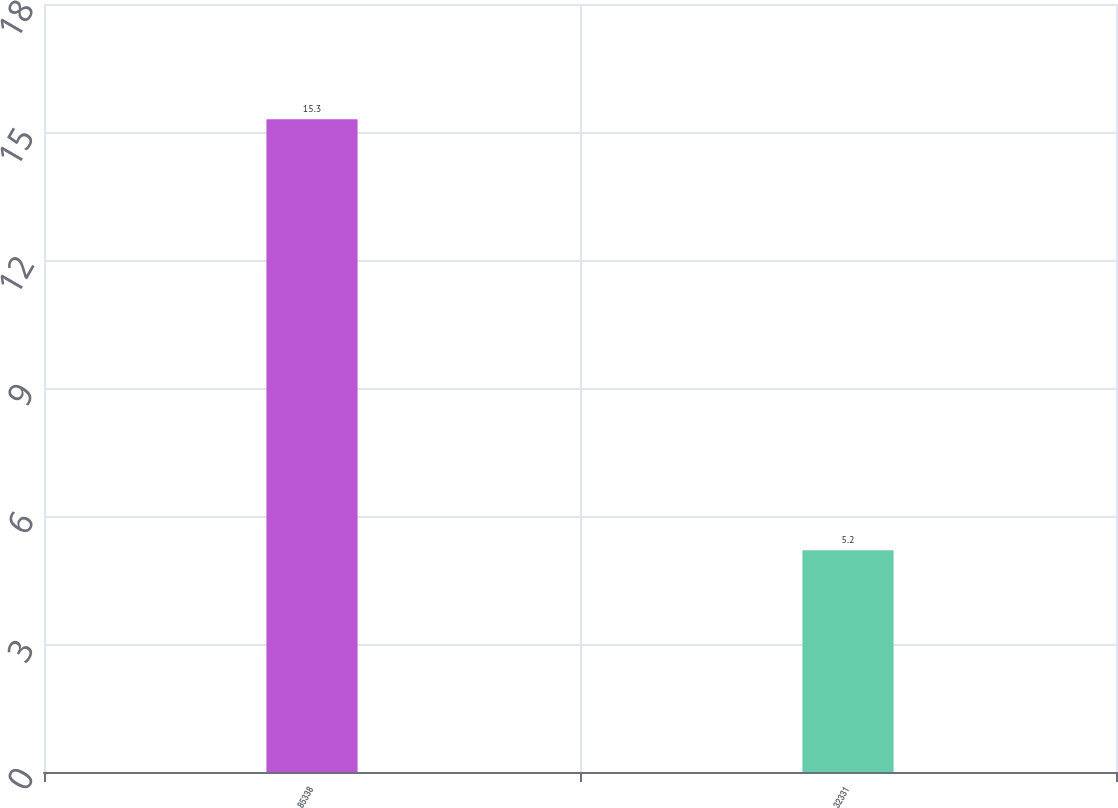<chart> <loc_0><loc_0><loc_500><loc_500><bar_chart><fcel>85338<fcel>32331<nl><fcel>15.3<fcel>5.2<nl></chart> 